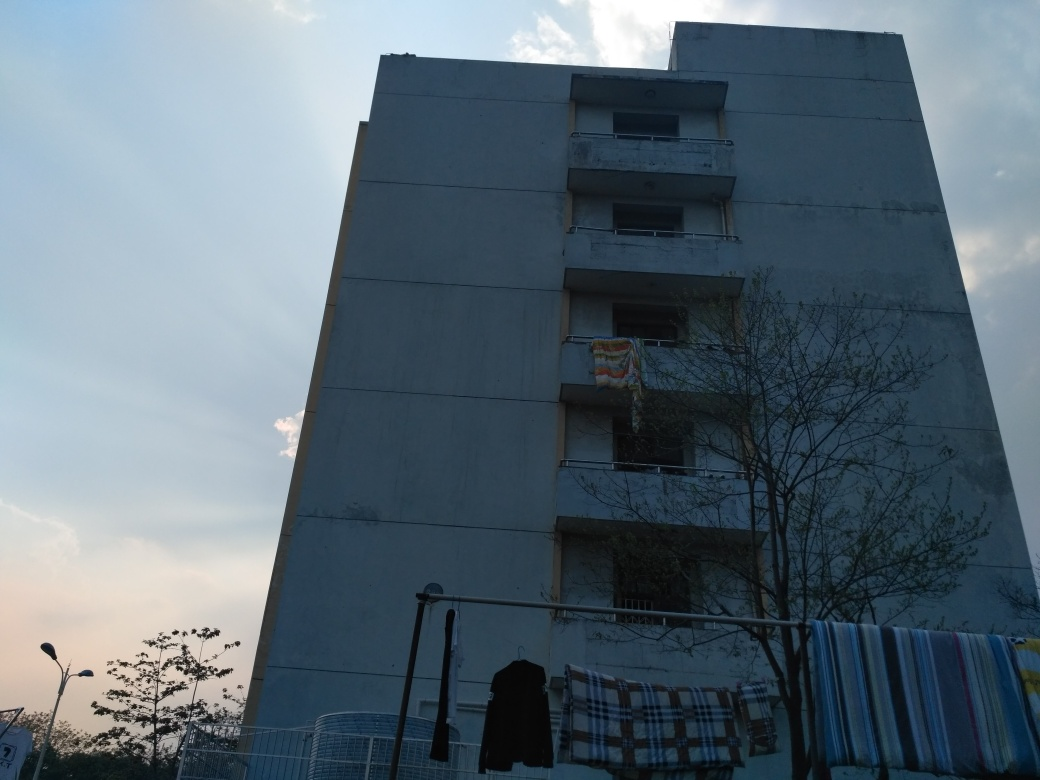Is the brightness relatively dark?
 Yes 